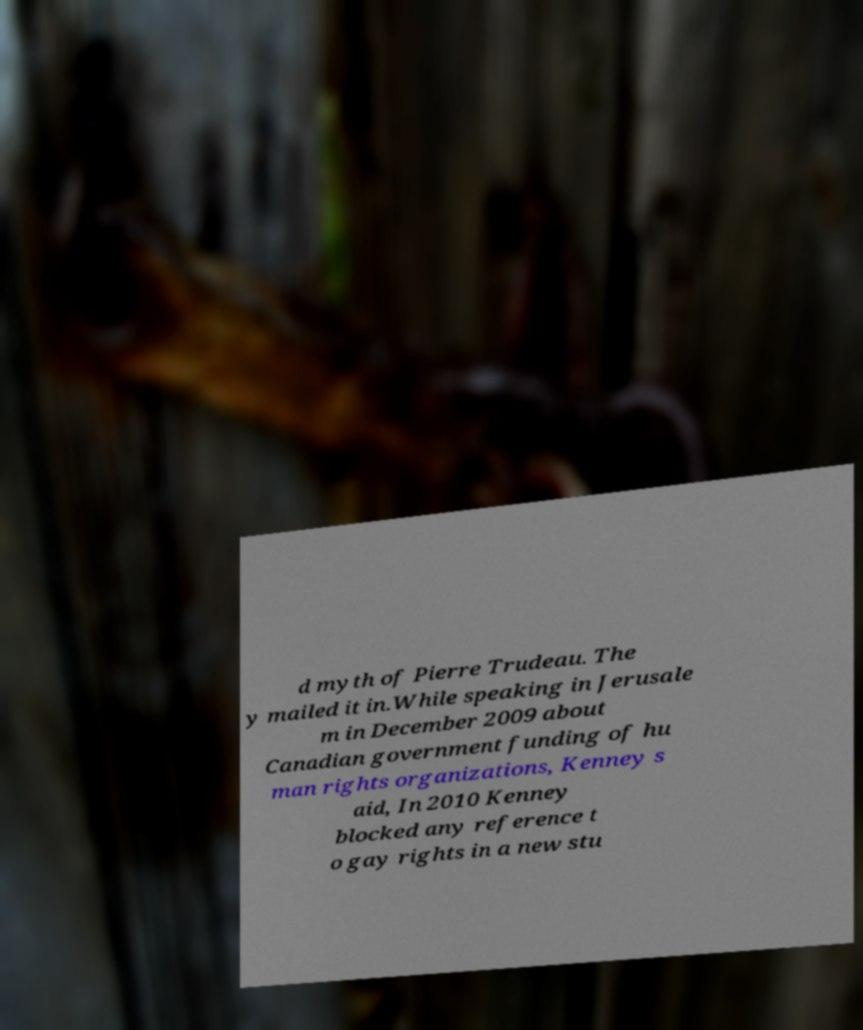For documentation purposes, I need the text within this image transcribed. Could you provide that? d myth of Pierre Trudeau. The y mailed it in.While speaking in Jerusale m in December 2009 about Canadian government funding of hu man rights organizations, Kenney s aid, In 2010 Kenney blocked any reference t o gay rights in a new stu 